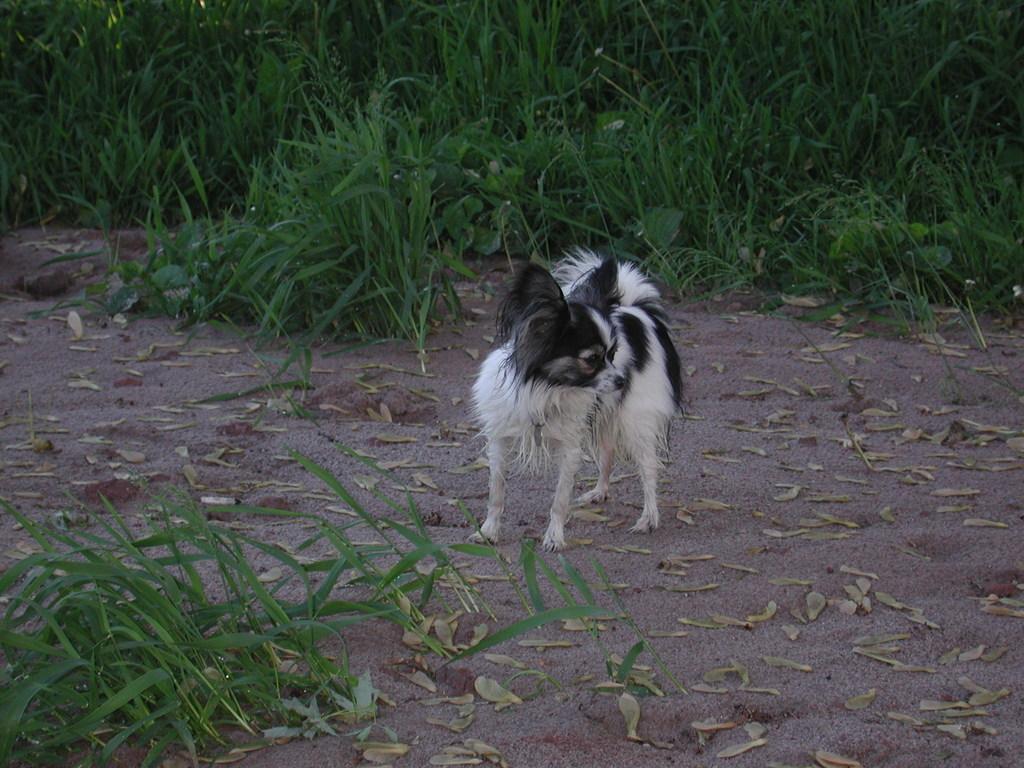In one or two sentences, can you explain what this image depicts? In this image I can see a white and black colour dog is standing on the ground. I can also see grass in the front and in the background of the image. 